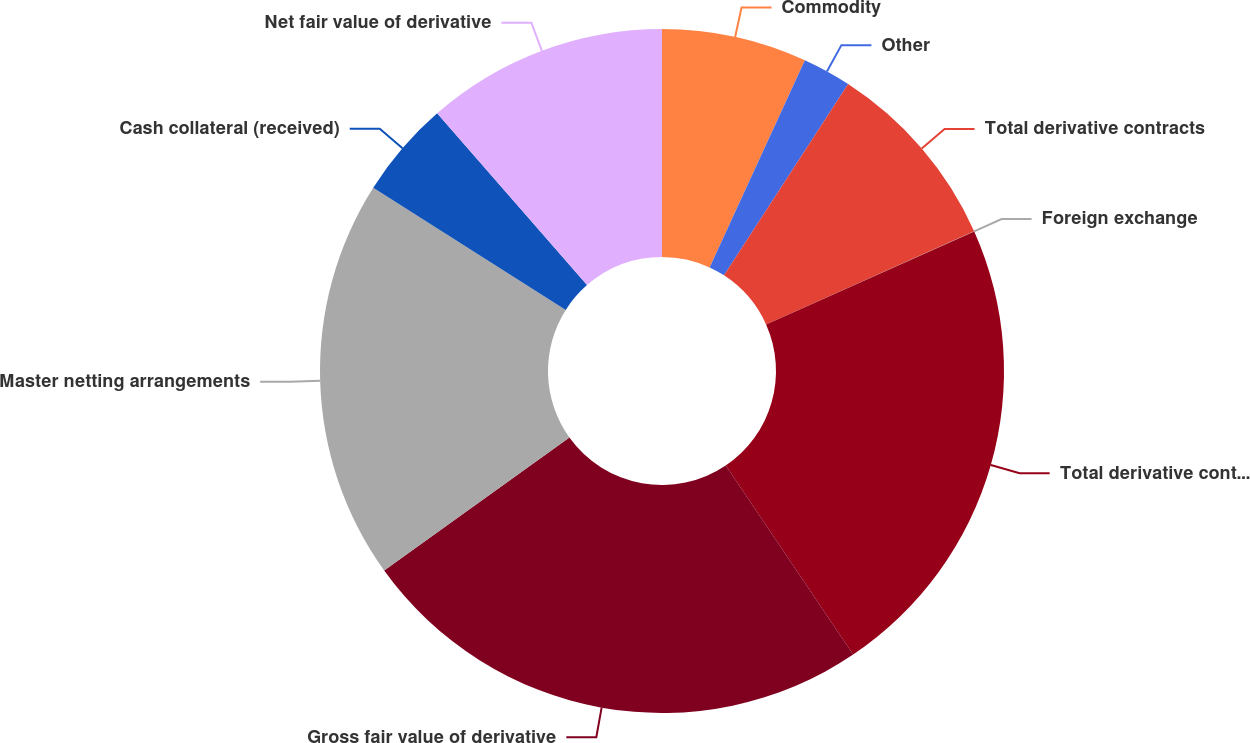<chart> <loc_0><loc_0><loc_500><loc_500><pie_chart><fcel>Commodity<fcel>Other<fcel>Total derivative contracts<fcel>Foreign exchange<fcel>Total derivative contracts not<fcel>Gross fair value of derivative<fcel>Master netting arrangements<fcel>Cash collateral (received)<fcel>Net fair value of derivative<nl><fcel>6.86%<fcel>2.3%<fcel>9.14%<fcel>0.01%<fcel>22.25%<fcel>24.53%<fcel>18.91%<fcel>4.58%<fcel>11.42%<nl></chart> 